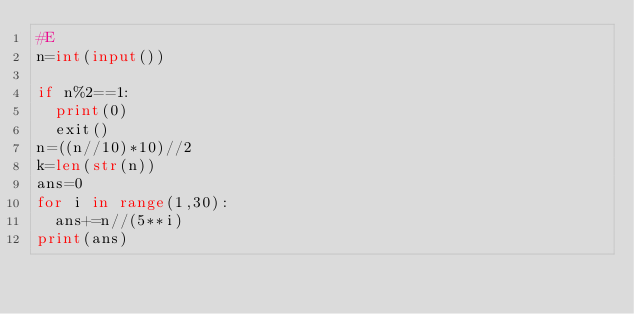<code> <loc_0><loc_0><loc_500><loc_500><_Python_>#E
n=int(input())

if n%2==1:
  print(0)
  exit()
n=((n//10)*10)//2
k=len(str(n))
ans=0
for i in range(1,30):
  ans+=n//(5**i)
print(ans)</code> 